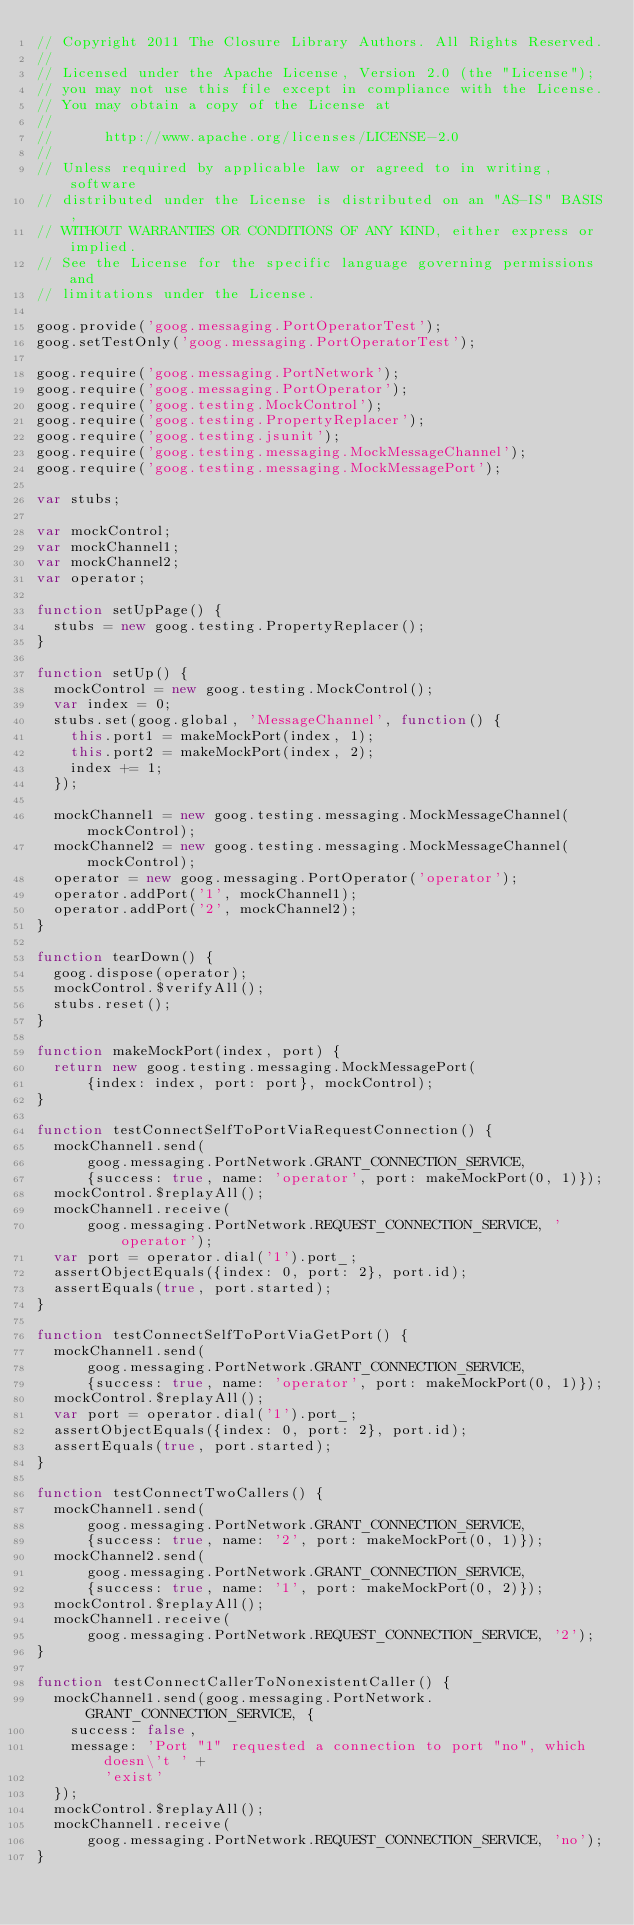<code> <loc_0><loc_0><loc_500><loc_500><_JavaScript_>// Copyright 2011 The Closure Library Authors. All Rights Reserved.
//
// Licensed under the Apache License, Version 2.0 (the "License");
// you may not use this file except in compliance with the License.
// You may obtain a copy of the License at
//
//      http://www.apache.org/licenses/LICENSE-2.0
//
// Unless required by applicable law or agreed to in writing, software
// distributed under the License is distributed on an "AS-IS" BASIS,
// WITHOUT WARRANTIES OR CONDITIONS OF ANY KIND, either express or implied.
// See the License for the specific language governing permissions and
// limitations under the License.

goog.provide('goog.messaging.PortOperatorTest');
goog.setTestOnly('goog.messaging.PortOperatorTest');

goog.require('goog.messaging.PortNetwork');
goog.require('goog.messaging.PortOperator');
goog.require('goog.testing.MockControl');
goog.require('goog.testing.PropertyReplacer');
goog.require('goog.testing.jsunit');
goog.require('goog.testing.messaging.MockMessageChannel');
goog.require('goog.testing.messaging.MockMessagePort');

var stubs;

var mockControl;
var mockChannel1;
var mockChannel2;
var operator;

function setUpPage() {
  stubs = new goog.testing.PropertyReplacer();
}

function setUp() {
  mockControl = new goog.testing.MockControl();
  var index = 0;
  stubs.set(goog.global, 'MessageChannel', function() {
    this.port1 = makeMockPort(index, 1);
    this.port2 = makeMockPort(index, 2);
    index += 1;
  });

  mockChannel1 = new goog.testing.messaging.MockMessageChannel(mockControl);
  mockChannel2 = new goog.testing.messaging.MockMessageChannel(mockControl);
  operator = new goog.messaging.PortOperator('operator');
  operator.addPort('1', mockChannel1);
  operator.addPort('2', mockChannel2);
}

function tearDown() {
  goog.dispose(operator);
  mockControl.$verifyAll();
  stubs.reset();
}

function makeMockPort(index, port) {
  return new goog.testing.messaging.MockMessagePort(
      {index: index, port: port}, mockControl);
}

function testConnectSelfToPortViaRequestConnection() {
  mockChannel1.send(
      goog.messaging.PortNetwork.GRANT_CONNECTION_SERVICE,
      {success: true, name: 'operator', port: makeMockPort(0, 1)});
  mockControl.$replayAll();
  mockChannel1.receive(
      goog.messaging.PortNetwork.REQUEST_CONNECTION_SERVICE, 'operator');
  var port = operator.dial('1').port_;
  assertObjectEquals({index: 0, port: 2}, port.id);
  assertEquals(true, port.started);
}

function testConnectSelfToPortViaGetPort() {
  mockChannel1.send(
      goog.messaging.PortNetwork.GRANT_CONNECTION_SERVICE,
      {success: true, name: 'operator', port: makeMockPort(0, 1)});
  mockControl.$replayAll();
  var port = operator.dial('1').port_;
  assertObjectEquals({index: 0, port: 2}, port.id);
  assertEquals(true, port.started);
}

function testConnectTwoCallers() {
  mockChannel1.send(
      goog.messaging.PortNetwork.GRANT_CONNECTION_SERVICE,
      {success: true, name: '2', port: makeMockPort(0, 1)});
  mockChannel2.send(
      goog.messaging.PortNetwork.GRANT_CONNECTION_SERVICE,
      {success: true, name: '1', port: makeMockPort(0, 2)});
  mockControl.$replayAll();
  mockChannel1.receive(
      goog.messaging.PortNetwork.REQUEST_CONNECTION_SERVICE, '2');
}

function testConnectCallerToNonexistentCaller() {
  mockChannel1.send(goog.messaging.PortNetwork.GRANT_CONNECTION_SERVICE, {
    success: false,
    message: 'Port "1" requested a connection to port "no", which doesn\'t ' +
        'exist'
  });
  mockControl.$replayAll();
  mockChannel1.receive(
      goog.messaging.PortNetwork.REQUEST_CONNECTION_SERVICE, 'no');
}
</code> 